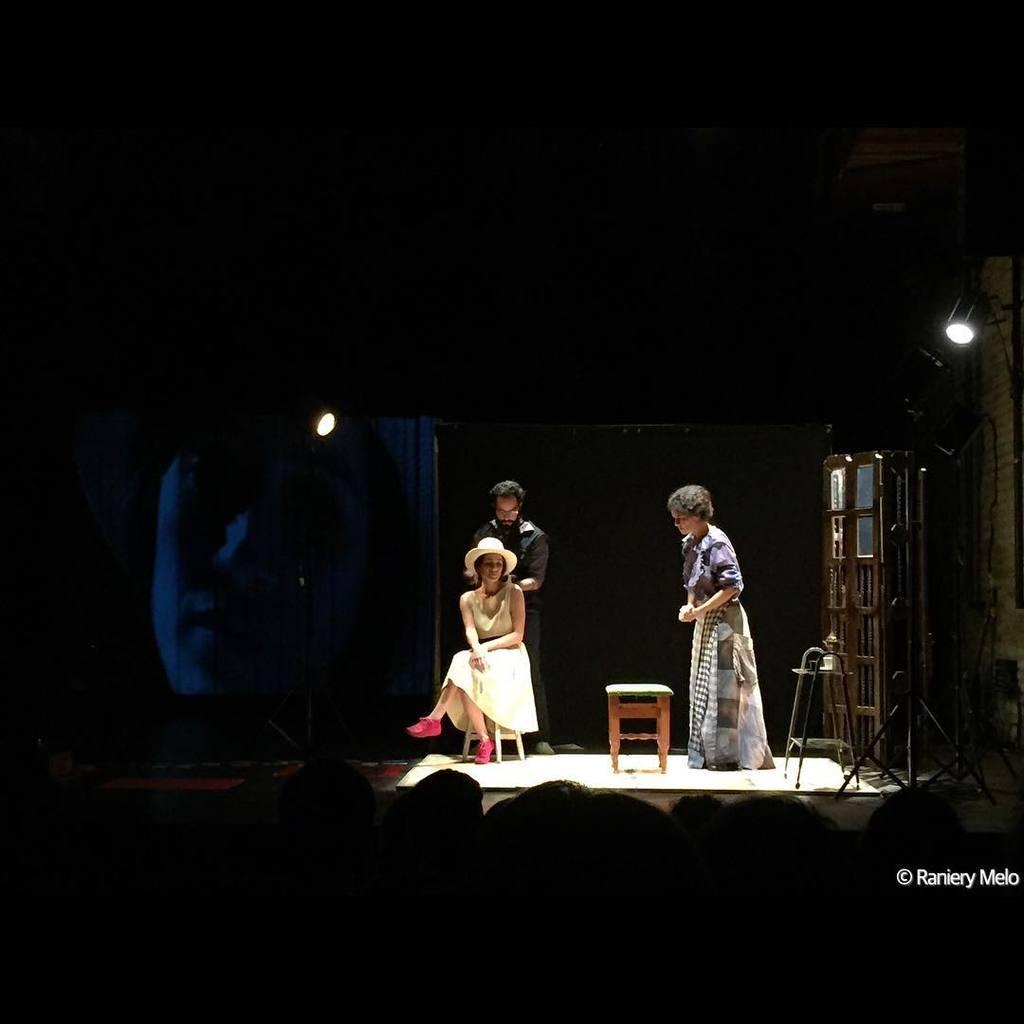Could you give a brief overview of what you see in this image? In this image we can see a man and woman standing on the floor and a woman sitting on the seating stool. In the background we can see a display screen and a side table with objects on it. 